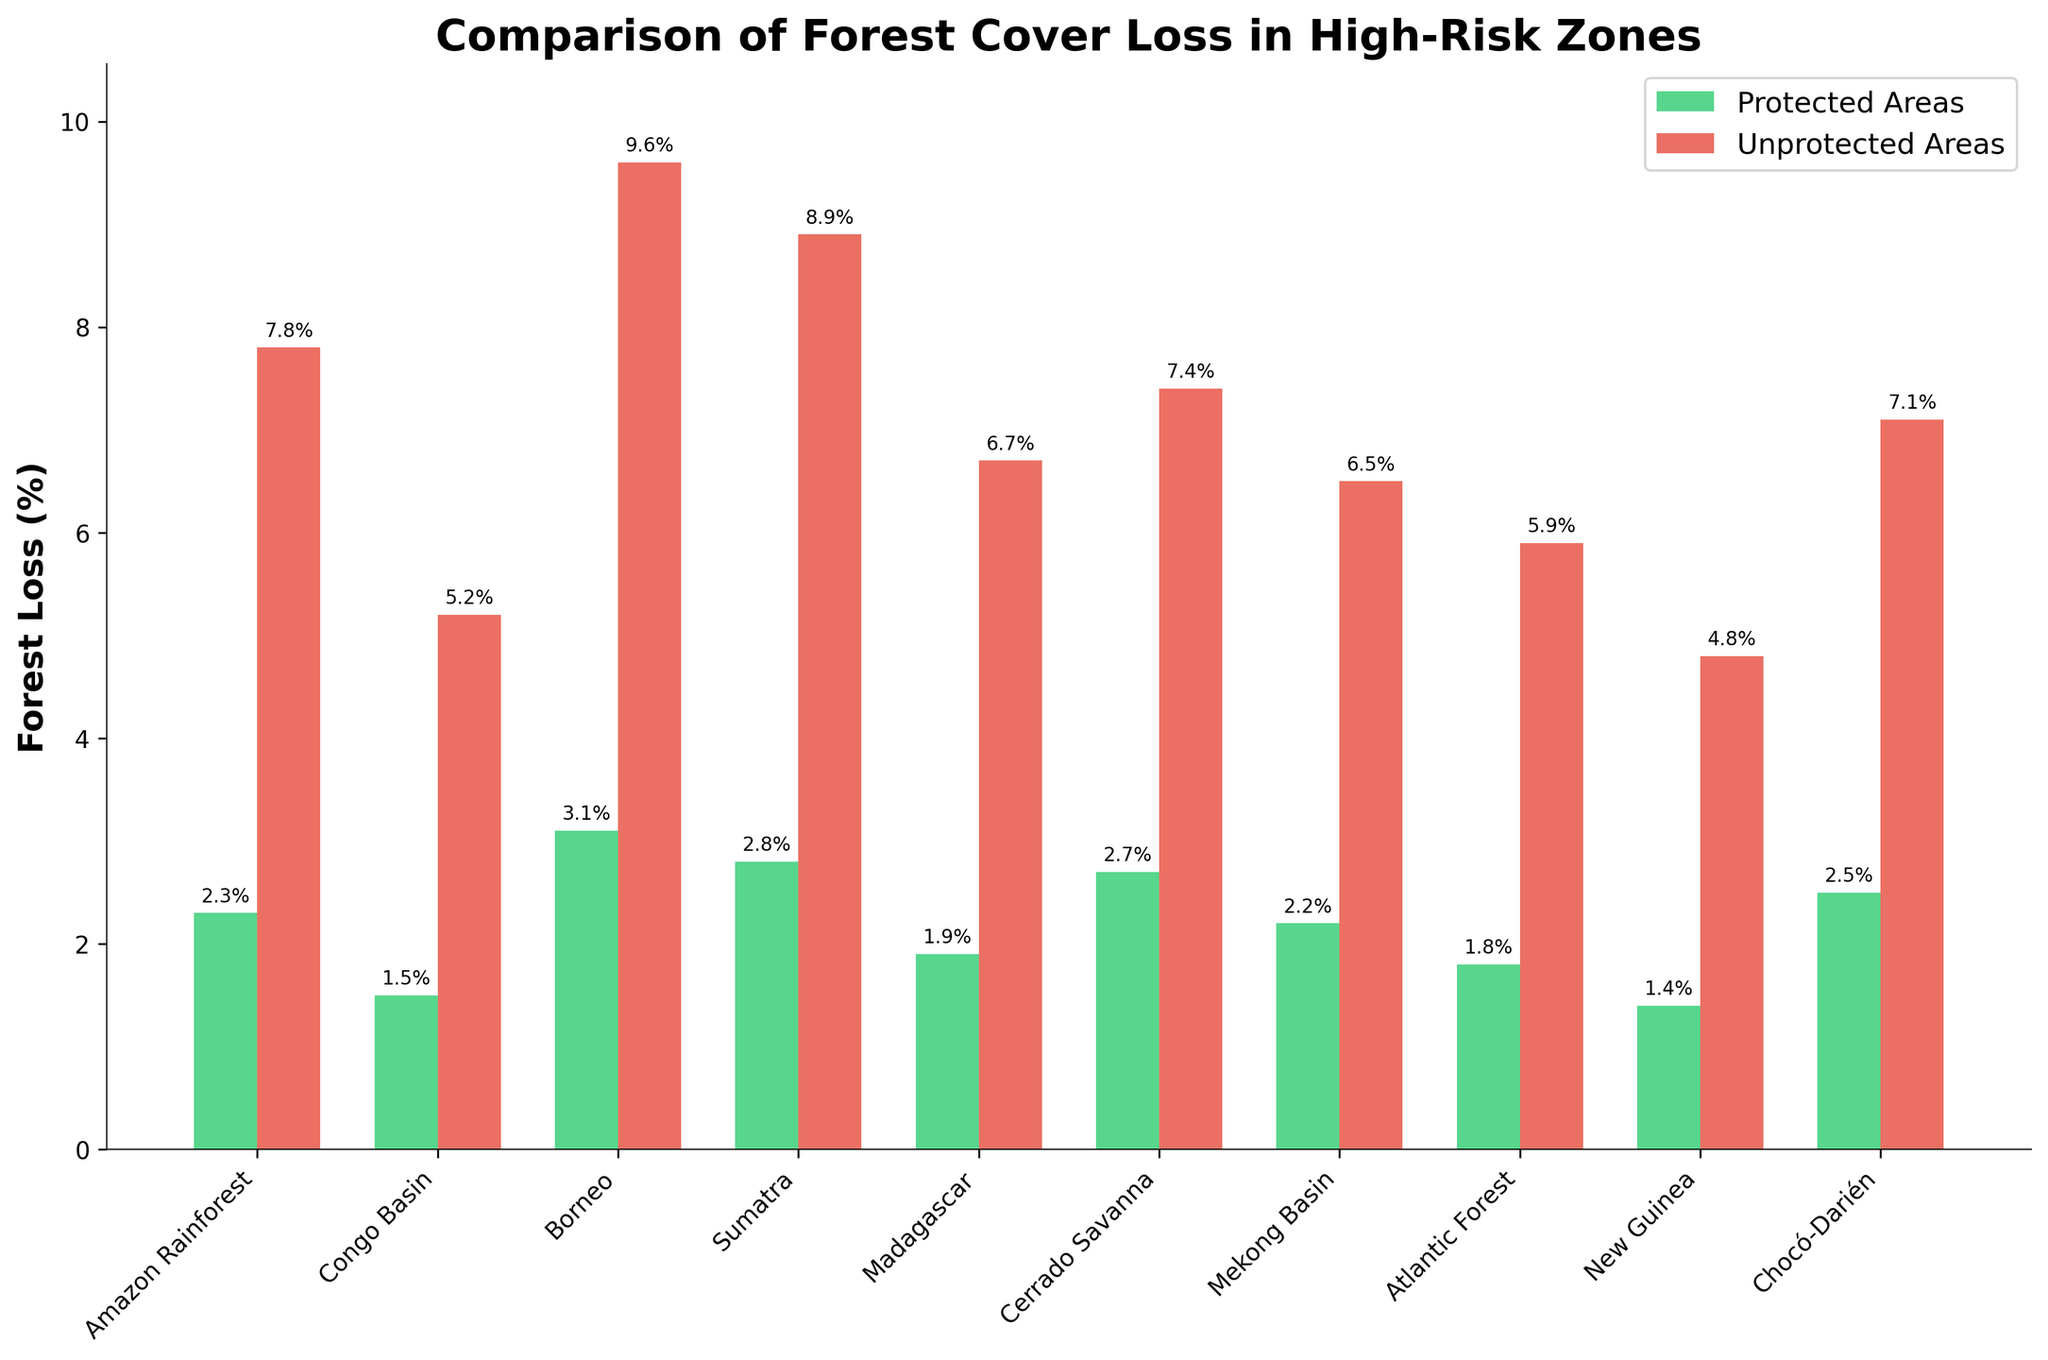Which region has the highest forest cover loss in unprotected areas? Compare the red bars (Unprotected Areas Forest Loss) across all regions, the highest bar belongs to Borneo.
Answer: Borneo Which region has the smallest difference between forest cover loss in protected and unprotected areas? Calculate the difference for each region: Amazon Rainforest (7.8-2.3=5.5), Congo Basin (5.2-1.5=3.7), Borneo (9.6-3.1=6.5), Sumatra (8.9-2.8=6.1), Madagascar (6.7-1.9=4.8), Cerrado Savanna (7.4-2.7=4.7), Mekong Basin (6.5-2.2=4.3), Atlantic Forest (5.9-1.8=4.1), New Guinea (4.8-1.4=3.4), Chocó-Darién (7.1-2.5=4.6). The smallest difference is found in New Guinea.
Answer: New Guinea What is the total forest cover loss percentage for protected and unprotected areas in the Amazon Rainforest? Add the forest loss percentages: (2.3 + 7.8 = 10.1)
Answer: 10.1 Which region shows a higher forest cover loss in protected areas compared to the average forest loss in unprotected areas across all regions? Calculate the average forest loss in unprotected areas: (7.8 + 5.2 + 9.6 + 8.9 + 6.7 + 7.4 + 6.5 + 5.9 + 4.8 + 7.1) / 10 = 6.99. Compare the green bars (Protected Areas Forest Loss) to this average. No region has a protected areas loss higher than 6.99.
Answer: None In which region is the disparity between forest cover loss in protected and unprotected areas the largest? Calculate the difference for each region: Amazon Rainforest (7.8-2.3=5.5), Congo Basin (5.2-1.5=3.7), Borneo (9.6-3.1=6.5), Sumatra (8.9-2.8=6.1), Madagascar (6.7-1.9=4.8), Cerrado Savanna (7.4-2.7=4.7), Mekong Basin (6.5-2.2=4.3), Atlantic Forest (5.9-1.8=4.1), New Guinea (4.8-1.4=3.4), Chocó-Darién (7.1-2.5=4.6). The largest disparity is in Borneo.
Answer: Borneo How many regions have less than 2% forest cover loss in protected areas? Examine the green bars (Protected Areas Forest Loss) to see which are below 2%: Congo Basin (1.5), New Guinea (1.4), Atlantic Forest (1.8). There are three regions.
Answer: 3 For which regions is the forest loss in unprotected areas more than triple that in protected areas? Check regions where unprotected forest loss is more than three times the protected: (Amazon Rainforest 7.8 > 3 * 2.3, Borneo 9.6 > 3 * 3.1, Sumatra 8.9 > 3 * 2.8). The conditions hold true for Amazon Rainforest, Borneo, Sumatra.
Answer: Amazon Rainforest, Borneo, Sumatra What is the visual difference in terms of height between protected and unprotected forest loss in Sumatra? Notice the height of green (protected 2.8) and red (unprotected 8.9) bars in Sumatra. The red bar is significantly taller than the green bar.
Answer: Red bar is significantly taller Which protected area has the least forest cover loss? Compare the heights of the green bars (Protected Areas Forest Loss): The smallest bar belongs to New Guinea.
Answer: New Guinea 